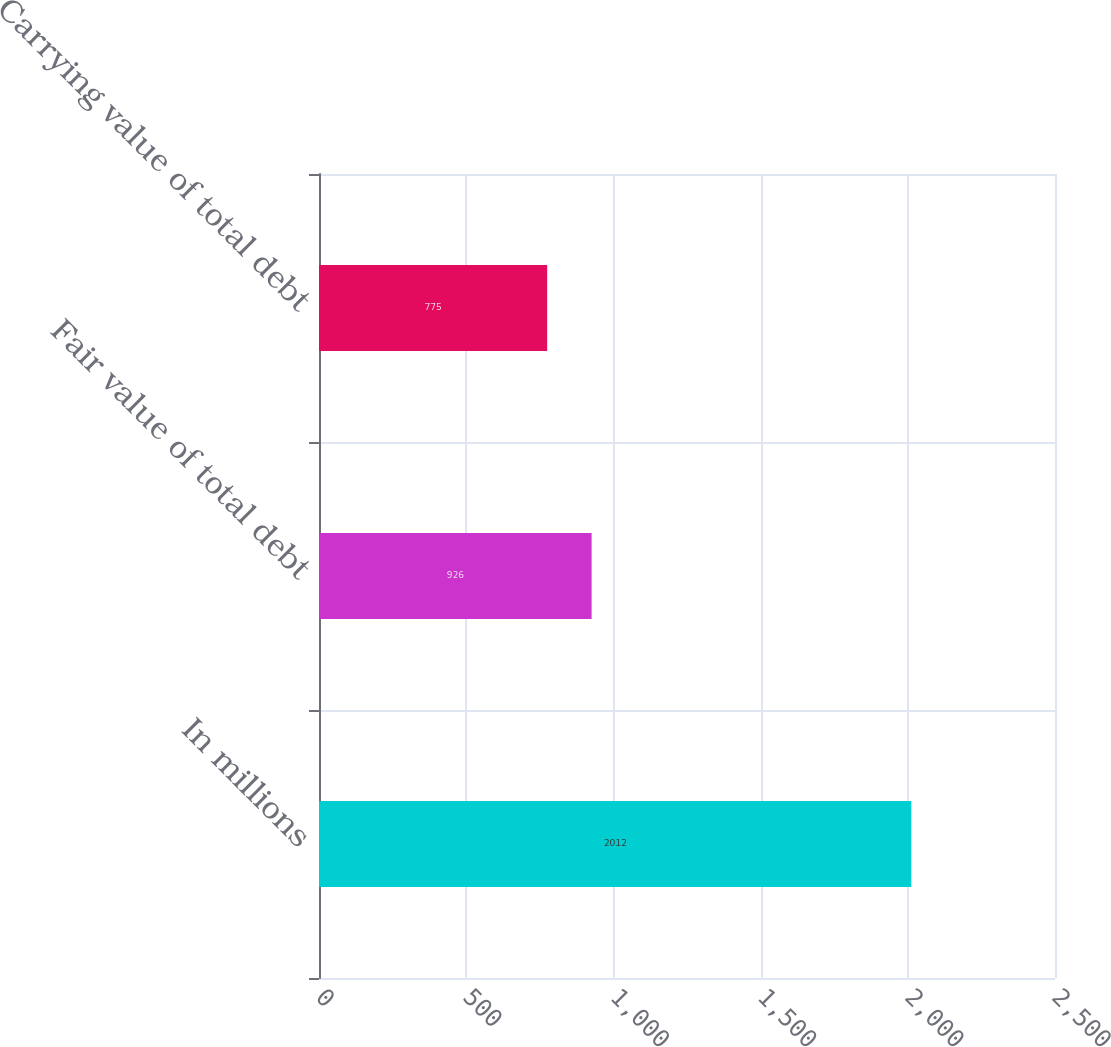<chart> <loc_0><loc_0><loc_500><loc_500><bar_chart><fcel>In millions<fcel>Fair value of total debt<fcel>Carrying value of total debt<nl><fcel>2012<fcel>926<fcel>775<nl></chart> 